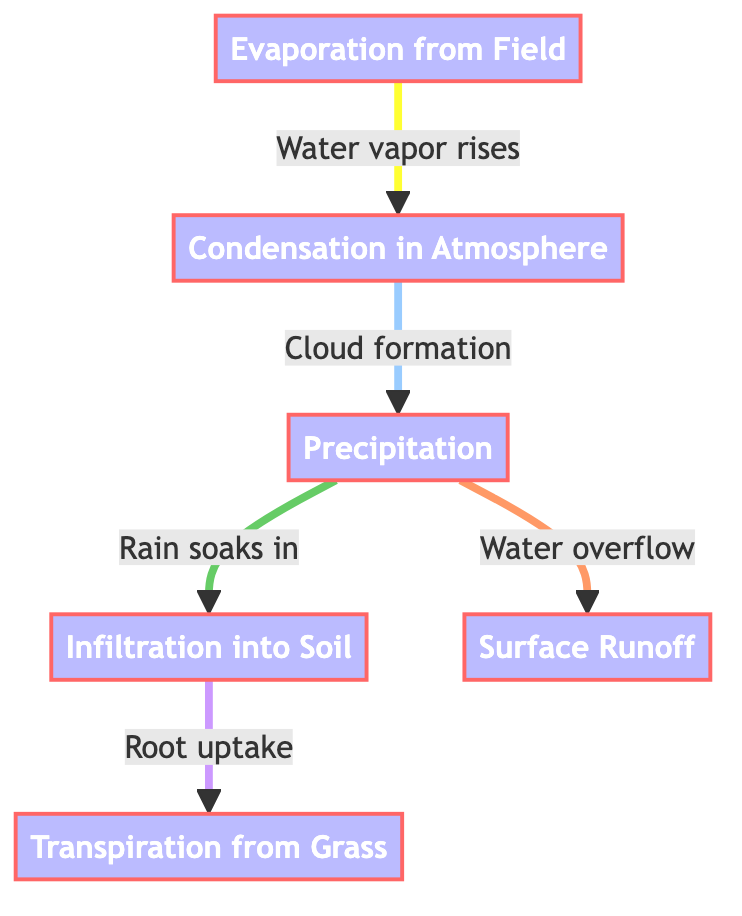What is the first step in the water cycle depicted in the diagram? The first step is labeled "Evaporation from Field," where water vapor rises into the atmosphere.
Answer: Evaporation from Field How many processes are represented in the diagram? There are six processes shown in the diagram: Evaporation from Field, Condensation in Atmosphere, Precipitation, Infiltration into Soil, Surface Runoff, and Transpiration from Grass.
Answer: Six What happens after condensation in the water cycle? After condensation, the next process is precipitation, which is represented as clouds forming and eventually leading to rain.
Answer: Precipitation What is the flow from Infiltration into Soil to Transpiration? The flow from Infiltration into Soil leads to root uptake, which then results in Transpiration from Grass. This demonstrates how water is utilized by plants.
Answer: Root uptake Which process results in surface runoff? Surface runoff occurs as a direct consequence of precipitation when excess water flows over the ground instead of being absorbed.
Answer: Precipitation Explain the relationship between Evaporation from Field and Transpiration from Grass. Evaporation from Field introduces water vapor into the atmosphere, while Transpiration from Grass, following root uptake, releases moisture back into the atmosphere. This creates a continuous cycle of water moving through the environment. Therefore, one contributes to the moisture level that enables the other.
Answer: They are interconnected processes in the water cycle What is the purpose of cloud formation in this diagram? Cloud formation leads to precipitation, which is essential for replenishing groundwater and supporting plant life through various processes shown in the diagram.
Answer: To lead to precipitation What is indicated by the arrow between Surface Runoff and precipitation? The arrow indicates that surface runoff can happen as a result of precipitation, showing a direct cause-effect relationship indicating how precipitation contributes to excess water that eventually runs off the field.
Answer: Water overflow What is the color of the process labeled "Condensation in Atmosphere"? The color of the process labeled "Condensation in Atmosphere" is defined as process blue, characterized by a light blue fill.
Answer: Light blue 